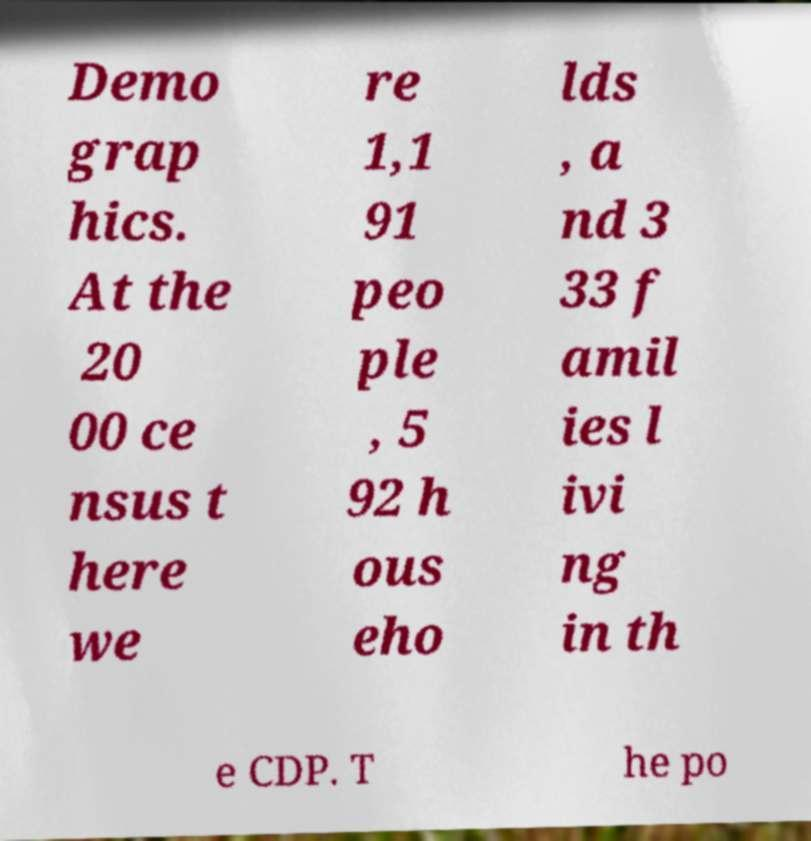What messages or text are displayed in this image? I need them in a readable, typed format. Demo grap hics. At the 20 00 ce nsus t here we re 1,1 91 peo ple , 5 92 h ous eho lds , a nd 3 33 f amil ies l ivi ng in th e CDP. T he po 